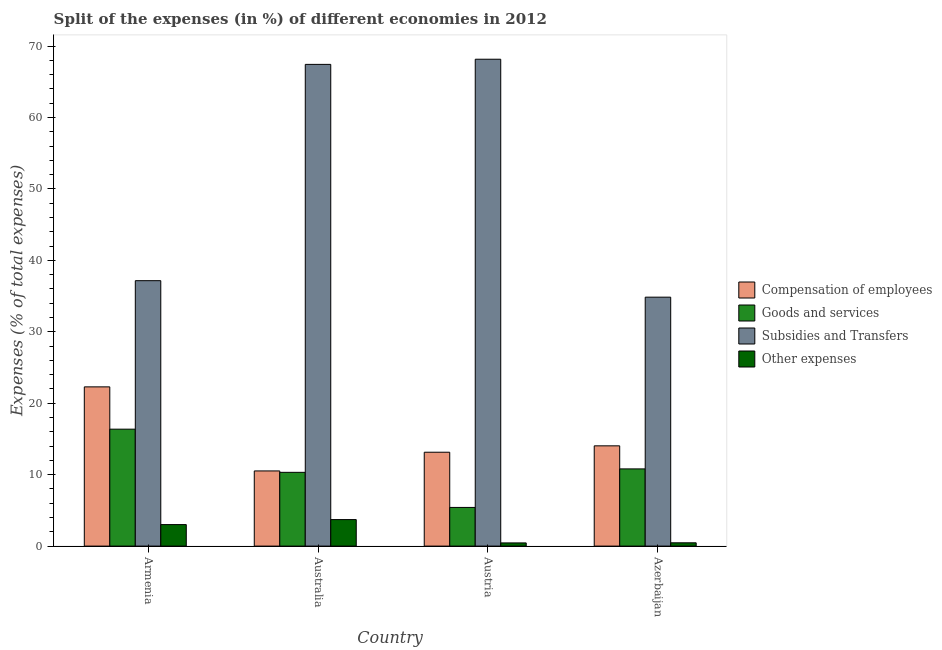How many different coloured bars are there?
Your response must be concise. 4. Are the number of bars on each tick of the X-axis equal?
Ensure brevity in your answer.  Yes. How many bars are there on the 4th tick from the right?
Offer a very short reply. 4. What is the percentage of amount spent on subsidies in Austria?
Give a very brief answer. 68.15. Across all countries, what is the maximum percentage of amount spent on other expenses?
Your answer should be very brief. 3.71. Across all countries, what is the minimum percentage of amount spent on other expenses?
Your answer should be compact. 0.45. What is the total percentage of amount spent on goods and services in the graph?
Offer a terse response. 42.91. What is the difference between the percentage of amount spent on goods and services in Austria and that in Azerbaijan?
Provide a short and direct response. -5.39. What is the difference between the percentage of amount spent on other expenses in Australia and the percentage of amount spent on compensation of employees in Armenia?
Give a very brief answer. -18.58. What is the average percentage of amount spent on subsidies per country?
Give a very brief answer. 51.89. What is the difference between the percentage of amount spent on subsidies and percentage of amount spent on other expenses in Armenia?
Provide a short and direct response. 34.14. In how many countries, is the percentage of amount spent on other expenses greater than 50 %?
Your response must be concise. 0. What is the ratio of the percentage of amount spent on goods and services in Armenia to that in Austria?
Provide a succinct answer. 3.02. What is the difference between the highest and the second highest percentage of amount spent on compensation of employees?
Ensure brevity in your answer.  8.25. What is the difference between the highest and the lowest percentage of amount spent on goods and services?
Your answer should be compact. 10.96. In how many countries, is the percentage of amount spent on subsidies greater than the average percentage of amount spent on subsidies taken over all countries?
Provide a succinct answer. 2. Is it the case that in every country, the sum of the percentage of amount spent on subsidies and percentage of amount spent on goods and services is greater than the sum of percentage of amount spent on compensation of employees and percentage of amount spent on other expenses?
Provide a succinct answer. No. What does the 2nd bar from the left in Australia represents?
Provide a succinct answer. Goods and services. What does the 1st bar from the right in Australia represents?
Provide a short and direct response. Other expenses. Are all the bars in the graph horizontal?
Offer a terse response. No. Does the graph contain any zero values?
Provide a short and direct response. No. Does the graph contain grids?
Offer a very short reply. No. How are the legend labels stacked?
Your response must be concise. Vertical. What is the title of the graph?
Your answer should be very brief. Split of the expenses (in %) of different economies in 2012. Does "Taxes on exports" appear as one of the legend labels in the graph?
Provide a short and direct response. No. What is the label or title of the Y-axis?
Offer a terse response. Expenses (% of total expenses). What is the Expenses (% of total expenses) in Compensation of employees in Armenia?
Provide a short and direct response. 22.29. What is the Expenses (% of total expenses) of Goods and services in Armenia?
Make the answer very short. 16.37. What is the Expenses (% of total expenses) in Subsidies and Transfers in Armenia?
Your answer should be compact. 37.15. What is the Expenses (% of total expenses) of Other expenses in Armenia?
Keep it short and to the point. 3.01. What is the Expenses (% of total expenses) in Compensation of employees in Australia?
Provide a short and direct response. 10.52. What is the Expenses (% of total expenses) in Goods and services in Australia?
Your answer should be compact. 10.32. What is the Expenses (% of total expenses) in Subsidies and Transfers in Australia?
Give a very brief answer. 67.43. What is the Expenses (% of total expenses) of Other expenses in Australia?
Offer a very short reply. 3.71. What is the Expenses (% of total expenses) of Compensation of employees in Austria?
Ensure brevity in your answer.  13.14. What is the Expenses (% of total expenses) of Goods and services in Austria?
Offer a very short reply. 5.41. What is the Expenses (% of total expenses) in Subsidies and Transfers in Austria?
Provide a succinct answer. 68.15. What is the Expenses (% of total expenses) in Other expenses in Austria?
Your answer should be very brief. 0.45. What is the Expenses (% of total expenses) in Compensation of employees in Azerbaijan?
Offer a terse response. 14.03. What is the Expenses (% of total expenses) in Goods and services in Azerbaijan?
Provide a succinct answer. 10.81. What is the Expenses (% of total expenses) of Subsidies and Transfers in Azerbaijan?
Your answer should be compact. 34.84. What is the Expenses (% of total expenses) in Other expenses in Azerbaijan?
Make the answer very short. 0.46. Across all countries, what is the maximum Expenses (% of total expenses) in Compensation of employees?
Offer a very short reply. 22.29. Across all countries, what is the maximum Expenses (% of total expenses) in Goods and services?
Your answer should be compact. 16.37. Across all countries, what is the maximum Expenses (% of total expenses) of Subsidies and Transfers?
Provide a succinct answer. 68.15. Across all countries, what is the maximum Expenses (% of total expenses) of Other expenses?
Give a very brief answer. 3.71. Across all countries, what is the minimum Expenses (% of total expenses) of Compensation of employees?
Your answer should be compact. 10.52. Across all countries, what is the minimum Expenses (% of total expenses) in Goods and services?
Keep it short and to the point. 5.41. Across all countries, what is the minimum Expenses (% of total expenses) of Subsidies and Transfers?
Provide a short and direct response. 34.84. Across all countries, what is the minimum Expenses (% of total expenses) in Other expenses?
Your answer should be very brief. 0.45. What is the total Expenses (% of total expenses) in Compensation of employees in the graph?
Provide a succinct answer. 59.98. What is the total Expenses (% of total expenses) of Goods and services in the graph?
Ensure brevity in your answer.  42.91. What is the total Expenses (% of total expenses) of Subsidies and Transfers in the graph?
Make the answer very short. 207.57. What is the total Expenses (% of total expenses) in Other expenses in the graph?
Your answer should be very brief. 7.63. What is the difference between the Expenses (% of total expenses) in Compensation of employees in Armenia and that in Australia?
Keep it short and to the point. 11.77. What is the difference between the Expenses (% of total expenses) of Goods and services in Armenia and that in Australia?
Provide a short and direct response. 6.04. What is the difference between the Expenses (% of total expenses) in Subsidies and Transfers in Armenia and that in Australia?
Make the answer very short. -30.28. What is the difference between the Expenses (% of total expenses) of Other expenses in Armenia and that in Australia?
Your response must be concise. -0.7. What is the difference between the Expenses (% of total expenses) in Compensation of employees in Armenia and that in Austria?
Provide a short and direct response. 9.15. What is the difference between the Expenses (% of total expenses) in Goods and services in Armenia and that in Austria?
Offer a very short reply. 10.96. What is the difference between the Expenses (% of total expenses) of Subsidies and Transfers in Armenia and that in Austria?
Provide a succinct answer. -31. What is the difference between the Expenses (% of total expenses) in Other expenses in Armenia and that in Austria?
Your response must be concise. 2.57. What is the difference between the Expenses (% of total expenses) of Compensation of employees in Armenia and that in Azerbaijan?
Offer a very short reply. 8.25. What is the difference between the Expenses (% of total expenses) in Goods and services in Armenia and that in Azerbaijan?
Keep it short and to the point. 5.56. What is the difference between the Expenses (% of total expenses) of Subsidies and Transfers in Armenia and that in Azerbaijan?
Offer a terse response. 2.31. What is the difference between the Expenses (% of total expenses) of Other expenses in Armenia and that in Azerbaijan?
Ensure brevity in your answer.  2.55. What is the difference between the Expenses (% of total expenses) of Compensation of employees in Australia and that in Austria?
Provide a short and direct response. -2.62. What is the difference between the Expenses (% of total expenses) in Goods and services in Australia and that in Austria?
Make the answer very short. 4.91. What is the difference between the Expenses (% of total expenses) of Subsidies and Transfers in Australia and that in Austria?
Your response must be concise. -0.72. What is the difference between the Expenses (% of total expenses) in Other expenses in Australia and that in Austria?
Offer a very short reply. 3.26. What is the difference between the Expenses (% of total expenses) in Compensation of employees in Australia and that in Azerbaijan?
Give a very brief answer. -3.51. What is the difference between the Expenses (% of total expenses) in Goods and services in Australia and that in Azerbaijan?
Make the answer very short. -0.48. What is the difference between the Expenses (% of total expenses) in Subsidies and Transfers in Australia and that in Azerbaijan?
Your response must be concise. 32.58. What is the difference between the Expenses (% of total expenses) in Other expenses in Australia and that in Azerbaijan?
Provide a short and direct response. 3.25. What is the difference between the Expenses (% of total expenses) of Compensation of employees in Austria and that in Azerbaijan?
Your answer should be compact. -0.89. What is the difference between the Expenses (% of total expenses) in Goods and services in Austria and that in Azerbaijan?
Provide a succinct answer. -5.39. What is the difference between the Expenses (% of total expenses) of Subsidies and Transfers in Austria and that in Azerbaijan?
Your response must be concise. 33.31. What is the difference between the Expenses (% of total expenses) in Other expenses in Austria and that in Azerbaijan?
Ensure brevity in your answer.  -0.01. What is the difference between the Expenses (% of total expenses) of Compensation of employees in Armenia and the Expenses (% of total expenses) of Goods and services in Australia?
Provide a succinct answer. 11.96. What is the difference between the Expenses (% of total expenses) of Compensation of employees in Armenia and the Expenses (% of total expenses) of Subsidies and Transfers in Australia?
Offer a terse response. -45.14. What is the difference between the Expenses (% of total expenses) of Compensation of employees in Armenia and the Expenses (% of total expenses) of Other expenses in Australia?
Offer a very short reply. 18.58. What is the difference between the Expenses (% of total expenses) of Goods and services in Armenia and the Expenses (% of total expenses) of Subsidies and Transfers in Australia?
Provide a succinct answer. -51.06. What is the difference between the Expenses (% of total expenses) in Goods and services in Armenia and the Expenses (% of total expenses) in Other expenses in Australia?
Give a very brief answer. 12.66. What is the difference between the Expenses (% of total expenses) in Subsidies and Transfers in Armenia and the Expenses (% of total expenses) in Other expenses in Australia?
Keep it short and to the point. 33.44. What is the difference between the Expenses (% of total expenses) in Compensation of employees in Armenia and the Expenses (% of total expenses) in Goods and services in Austria?
Ensure brevity in your answer.  16.88. What is the difference between the Expenses (% of total expenses) of Compensation of employees in Armenia and the Expenses (% of total expenses) of Subsidies and Transfers in Austria?
Your answer should be compact. -45.86. What is the difference between the Expenses (% of total expenses) in Compensation of employees in Armenia and the Expenses (% of total expenses) in Other expenses in Austria?
Make the answer very short. 21.84. What is the difference between the Expenses (% of total expenses) in Goods and services in Armenia and the Expenses (% of total expenses) in Subsidies and Transfers in Austria?
Make the answer very short. -51.78. What is the difference between the Expenses (% of total expenses) of Goods and services in Armenia and the Expenses (% of total expenses) of Other expenses in Austria?
Keep it short and to the point. 15.92. What is the difference between the Expenses (% of total expenses) of Subsidies and Transfers in Armenia and the Expenses (% of total expenses) of Other expenses in Austria?
Offer a terse response. 36.7. What is the difference between the Expenses (% of total expenses) in Compensation of employees in Armenia and the Expenses (% of total expenses) in Goods and services in Azerbaijan?
Keep it short and to the point. 11.48. What is the difference between the Expenses (% of total expenses) in Compensation of employees in Armenia and the Expenses (% of total expenses) in Subsidies and Transfers in Azerbaijan?
Your answer should be very brief. -12.56. What is the difference between the Expenses (% of total expenses) in Compensation of employees in Armenia and the Expenses (% of total expenses) in Other expenses in Azerbaijan?
Your response must be concise. 21.83. What is the difference between the Expenses (% of total expenses) of Goods and services in Armenia and the Expenses (% of total expenses) of Subsidies and Transfers in Azerbaijan?
Your answer should be very brief. -18.48. What is the difference between the Expenses (% of total expenses) in Goods and services in Armenia and the Expenses (% of total expenses) in Other expenses in Azerbaijan?
Give a very brief answer. 15.91. What is the difference between the Expenses (% of total expenses) in Subsidies and Transfers in Armenia and the Expenses (% of total expenses) in Other expenses in Azerbaijan?
Give a very brief answer. 36.69. What is the difference between the Expenses (% of total expenses) in Compensation of employees in Australia and the Expenses (% of total expenses) in Goods and services in Austria?
Provide a short and direct response. 5.11. What is the difference between the Expenses (% of total expenses) of Compensation of employees in Australia and the Expenses (% of total expenses) of Subsidies and Transfers in Austria?
Give a very brief answer. -57.63. What is the difference between the Expenses (% of total expenses) in Compensation of employees in Australia and the Expenses (% of total expenses) in Other expenses in Austria?
Ensure brevity in your answer.  10.07. What is the difference between the Expenses (% of total expenses) in Goods and services in Australia and the Expenses (% of total expenses) in Subsidies and Transfers in Austria?
Keep it short and to the point. -57.83. What is the difference between the Expenses (% of total expenses) in Goods and services in Australia and the Expenses (% of total expenses) in Other expenses in Austria?
Offer a very short reply. 9.88. What is the difference between the Expenses (% of total expenses) in Subsidies and Transfers in Australia and the Expenses (% of total expenses) in Other expenses in Austria?
Keep it short and to the point. 66.98. What is the difference between the Expenses (% of total expenses) in Compensation of employees in Australia and the Expenses (% of total expenses) in Goods and services in Azerbaijan?
Offer a very short reply. -0.29. What is the difference between the Expenses (% of total expenses) of Compensation of employees in Australia and the Expenses (% of total expenses) of Subsidies and Transfers in Azerbaijan?
Keep it short and to the point. -24.32. What is the difference between the Expenses (% of total expenses) of Compensation of employees in Australia and the Expenses (% of total expenses) of Other expenses in Azerbaijan?
Give a very brief answer. 10.06. What is the difference between the Expenses (% of total expenses) in Goods and services in Australia and the Expenses (% of total expenses) in Subsidies and Transfers in Azerbaijan?
Your answer should be very brief. -24.52. What is the difference between the Expenses (% of total expenses) in Goods and services in Australia and the Expenses (% of total expenses) in Other expenses in Azerbaijan?
Provide a succinct answer. 9.86. What is the difference between the Expenses (% of total expenses) of Subsidies and Transfers in Australia and the Expenses (% of total expenses) of Other expenses in Azerbaijan?
Make the answer very short. 66.97. What is the difference between the Expenses (% of total expenses) of Compensation of employees in Austria and the Expenses (% of total expenses) of Goods and services in Azerbaijan?
Your answer should be compact. 2.33. What is the difference between the Expenses (% of total expenses) in Compensation of employees in Austria and the Expenses (% of total expenses) in Subsidies and Transfers in Azerbaijan?
Your response must be concise. -21.71. What is the difference between the Expenses (% of total expenses) of Compensation of employees in Austria and the Expenses (% of total expenses) of Other expenses in Azerbaijan?
Your answer should be very brief. 12.68. What is the difference between the Expenses (% of total expenses) of Goods and services in Austria and the Expenses (% of total expenses) of Subsidies and Transfers in Azerbaijan?
Your answer should be compact. -29.43. What is the difference between the Expenses (% of total expenses) of Goods and services in Austria and the Expenses (% of total expenses) of Other expenses in Azerbaijan?
Keep it short and to the point. 4.95. What is the difference between the Expenses (% of total expenses) of Subsidies and Transfers in Austria and the Expenses (% of total expenses) of Other expenses in Azerbaijan?
Offer a terse response. 67.69. What is the average Expenses (% of total expenses) of Compensation of employees per country?
Give a very brief answer. 15. What is the average Expenses (% of total expenses) of Goods and services per country?
Make the answer very short. 10.73. What is the average Expenses (% of total expenses) in Subsidies and Transfers per country?
Your answer should be very brief. 51.89. What is the average Expenses (% of total expenses) of Other expenses per country?
Ensure brevity in your answer.  1.91. What is the difference between the Expenses (% of total expenses) in Compensation of employees and Expenses (% of total expenses) in Goods and services in Armenia?
Your answer should be compact. 5.92. What is the difference between the Expenses (% of total expenses) of Compensation of employees and Expenses (% of total expenses) of Subsidies and Transfers in Armenia?
Offer a terse response. -14.86. What is the difference between the Expenses (% of total expenses) of Compensation of employees and Expenses (% of total expenses) of Other expenses in Armenia?
Keep it short and to the point. 19.28. What is the difference between the Expenses (% of total expenses) of Goods and services and Expenses (% of total expenses) of Subsidies and Transfers in Armenia?
Make the answer very short. -20.78. What is the difference between the Expenses (% of total expenses) of Goods and services and Expenses (% of total expenses) of Other expenses in Armenia?
Offer a terse response. 13.36. What is the difference between the Expenses (% of total expenses) in Subsidies and Transfers and Expenses (% of total expenses) in Other expenses in Armenia?
Provide a short and direct response. 34.14. What is the difference between the Expenses (% of total expenses) in Compensation of employees and Expenses (% of total expenses) in Goods and services in Australia?
Your answer should be very brief. 0.2. What is the difference between the Expenses (% of total expenses) of Compensation of employees and Expenses (% of total expenses) of Subsidies and Transfers in Australia?
Keep it short and to the point. -56.91. What is the difference between the Expenses (% of total expenses) of Compensation of employees and Expenses (% of total expenses) of Other expenses in Australia?
Your response must be concise. 6.81. What is the difference between the Expenses (% of total expenses) in Goods and services and Expenses (% of total expenses) in Subsidies and Transfers in Australia?
Ensure brevity in your answer.  -57.1. What is the difference between the Expenses (% of total expenses) in Goods and services and Expenses (% of total expenses) in Other expenses in Australia?
Keep it short and to the point. 6.61. What is the difference between the Expenses (% of total expenses) of Subsidies and Transfers and Expenses (% of total expenses) of Other expenses in Australia?
Provide a succinct answer. 63.72. What is the difference between the Expenses (% of total expenses) of Compensation of employees and Expenses (% of total expenses) of Goods and services in Austria?
Offer a terse response. 7.73. What is the difference between the Expenses (% of total expenses) in Compensation of employees and Expenses (% of total expenses) in Subsidies and Transfers in Austria?
Give a very brief answer. -55.01. What is the difference between the Expenses (% of total expenses) in Compensation of employees and Expenses (% of total expenses) in Other expenses in Austria?
Keep it short and to the point. 12.69. What is the difference between the Expenses (% of total expenses) in Goods and services and Expenses (% of total expenses) in Subsidies and Transfers in Austria?
Ensure brevity in your answer.  -62.74. What is the difference between the Expenses (% of total expenses) of Goods and services and Expenses (% of total expenses) of Other expenses in Austria?
Make the answer very short. 4.97. What is the difference between the Expenses (% of total expenses) in Subsidies and Transfers and Expenses (% of total expenses) in Other expenses in Austria?
Offer a very short reply. 67.7. What is the difference between the Expenses (% of total expenses) of Compensation of employees and Expenses (% of total expenses) of Goods and services in Azerbaijan?
Provide a short and direct response. 3.23. What is the difference between the Expenses (% of total expenses) in Compensation of employees and Expenses (% of total expenses) in Subsidies and Transfers in Azerbaijan?
Make the answer very short. -20.81. What is the difference between the Expenses (% of total expenses) of Compensation of employees and Expenses (% of total expenses) of Other expenses in Azerbaijan?
Keep it short and to the point. 13.57. What is the difference between the Expenses (% of total expenses) of Goods and services and Expenses (% of total expenses) of Subsidies and Transfers in Azerbaijan?
Provide a succinct answer. -24.04. What is the difference between the Expenses (% of total expenses) of Goods and services and Expenses (% of total expenses) of Other expenses in Azerbaijan?
Keep it short and to the point. 10.35. What is the difference between the Expenses (% of total expenses) of Subsidies and Transfers and Expenses (% of total expenses) of Other expenses in Azerbaijan?
Offer a terse response. 34.38. What is the ratio of the Expenses (% of total expenses) in Compensation of employees in Armenia to that in Australia?
Offer a very short reply. 2.12. What is the ratio of the Expenses (% of total expenses) in Goods and services in Armenia to that in Australia?
Make the answer very short. 1.59. What is the ratio of the Expenses (% of total expenses) of Subsidies and Transfers in Armenia to that in Australia?
Ensure brevity in your answer.  0.55. What is the ratio of the Expenses (% of total expenses) in Other expenses in Armenia to that in Australia?
Keep it short and to the point. 0.81. What is the ratio of the Expenses (% of total expenses) in Compensation of employees in Armenia to that in Austria?
Your answer should be compact. 1.7. What is the ratio of the Expenses (% of total expenses) in Goods and services in Armenia to that in Austria?
Your answer should be very brief. 3.02. What is the ratio of the Expenses (% of total expenses) of Subsidies and Transfers in Armenia to that in Austria?
Your answer should be very brief. 0.55. What is the ratio of the Expenses (% of total expenses) in Other expenses in Armenia to that in Austria?
Offer a very short reply. 6.75. What is the ratio of the Expenses (% of total expenses) in Compensation of employees in Armenia to that in Azerbaijan?
Provide a succinct answer. 1.59. What is the ratio of the Expenses (% of total expenses) of Goods and services in Armenia to that in Azerbaijan?
Make the answer very short. 1.51. What is the ratio of the Expenses (% of total expenses) in Subsidies and Transfers in Armenia to that in Azerbaijan?
Your answer should be very brief. 1.07. What is the ratio of the Expenses (% of total expenses) of Other expenses in Armenia to that in Azerbaijan?
Give a very brief answer. 6.53. What is the ratio of the Expenses (% of total expenses) of Compensation of employees in Australia to that in Austria?
Your answer should be compact. 0.8. What is the ratio of the Expenses (% of total expenses) of Goods and services in Australia to that in Austria?
Make the answer very short. 1.91. What is the ratio of the Expenses (% of total expenses) in Subsidies and Transfers in Australia to that in Austria?
Offer a very short reply. 0.99. What is the ratio of the Expenses (% of total expenses) of Other expenses in Australia to that in Austria?
Offer a very short reply. 8.31. What is the ratio of the Expenses (% of total expenses) of Compensation of employees in Australia to that in Azerbaijan?
Ensure brevity in your answer.  0.75. What is the ratio of the Expenses (% of total expenses) in Goods and services in Australia to that in Azerbaijan?
Give a very brief answer. 0.96. What is the ratio of the Expenses (% of total expenses) of Subsidies and Transfers in Australia to that in Azerbaijan?
Your response must be concise. 1.94. What is the ratio of the Expenses (% of total expenses) in Other expenses in Australia to that in Azerbaijan?
Ensure brevity in your answer.  8.05. What is the ratio of the Expenses (% of total expenses) in Compensation of employees in Austria to that in Azerbaijan?
Make the answer very short. 0.94. What is the ratio of the Expenses (% of total expenses) of Goods and services in Austria to that in Azerbaijan?
Make the answer very short. 0.5. What is the ratio of the Expenses (% of total expenses) in Subsidies and Transfers in Austria to that in Azerbaijan?
Provide a short and direct response. 1.96. What is the ratio of the Expenses (% of total expenses) in Other expenses in Austria to that in Azerbaijan?
Provide a succinct answer. 0.97. What is the difference between the highest and the second highest Expenses (% of total expenses) of Compensation of employees?
Ensure brevity in your answer.  8.25. What is the difference between the highest and the second highest Expenses (% of total expenses) of Goods and services?
Offer a very short reply. 5.56. What is the difference between the highest and the second highest Expenses (% of total expenses) in Subsidies and Transfers?
Provide a short and direct response. 0.72. What is the difference between the highest and the second highest Expenses (% of total expenses) of Other expenses?
Keep it short and to the point. 0.7. What is the difference between the highest and the lowest Expenses (% of total expenses) in Compensation of employees?
Ensure brevity in your answer.  11.77. What is the difference between the highest and the lowest Expenses (% of total expenses) in Goods and services?
Offer a very short reply. 10.96. What is the difference between the highest and the lowest Expenses (% of total expenses) in Subsidies and Transfers?
Make the answer very short. 33.31. What is the difference between the highest and the lowest Expenses (% of total expenses) of Other expenses?
Offer a very short reply. 3.26. 